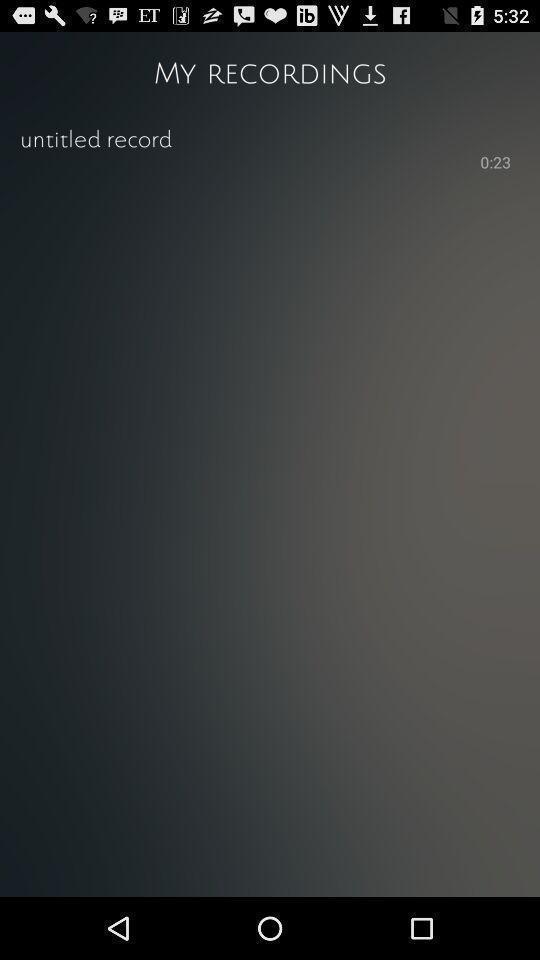What can you discern from this picture? Screen shows recordings page. 